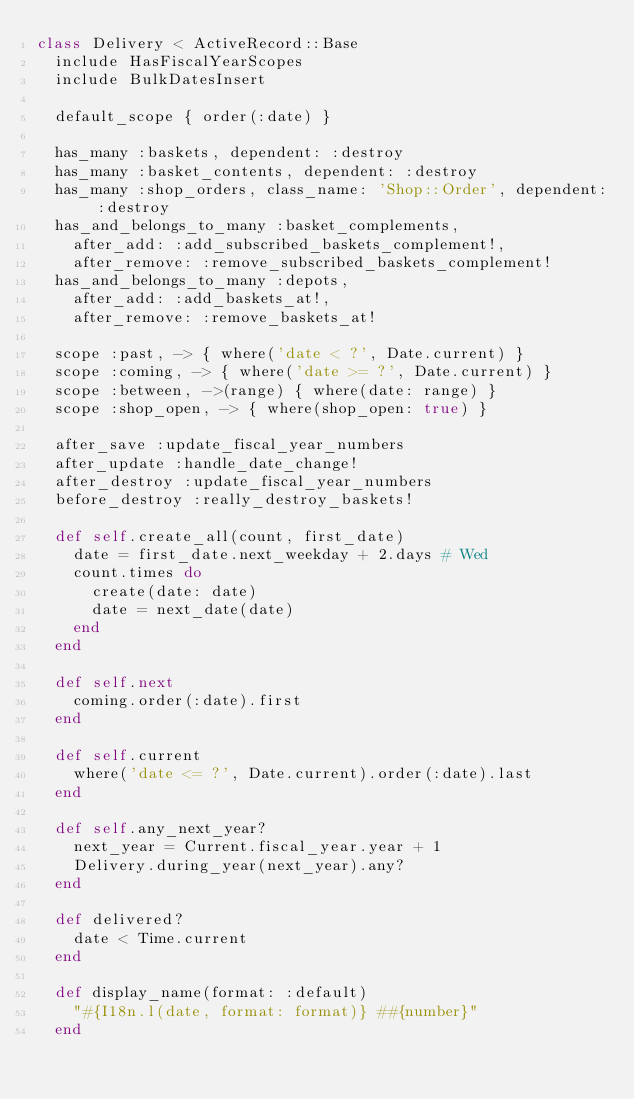<code> <loc_0><loc_0><loc_500><loc_500><_Ruby_>class Delivery < ActiveRecord::Base
  include HasFiscalYearScopes
  include BulkDatesInsert

  default_scope { order(:date) }

  has_many :baskets, dependent: :destroy
  has_many :basket_contents, dependent: :destroy
  has_many :shop_orders, class_name: 'Shop::Order', dependent: :destroy
  has_and_belongs_to_many :basket_complements,
    after_add: :add_subscribed_baskets_complement!,
    after_remove: :remove_subscribed_baskets_complement!
  has_and_belongs_to_many :depots,
    after_add: :add_baskets_at!,
    after_remove: :remove_baskets_at!

  scope :past, -> { where('date < ?', Date.current) }
  scope :coming, -> { where('date >= ?', Date.current) }
  scope :between, ->(range) { where(date: range) }
  scope :shop_open, -> { where(shop_open: true) }

  after_save :update_fiscal_year_numbers
  after_update :handle_date_change!
  after_destroy :update_fiscal_year_numbers
  before_destroy :really_destroy_baskets!

  def self.create_all(count, first_date)
    date = first_date.next_weekday + 2.days # Wed
    count.times do
      create(date: date)
      date = next_date(date)
    end
  end

  def self.next
    coming.order(:date).first
  end

  def self.current
    where('date <= ?', Date.current).order(:date).last
  end

  def self.any_next_year?
    next_year = Current.fiscal_year.year + 1
    Delivery.during_year(next_year).any?
  end

  def delivered?
    date < Time.current
  end

  def display_name(format: :default)
    "#{I18n.l(date, format: format)} ##{number}"
  end
</code> 